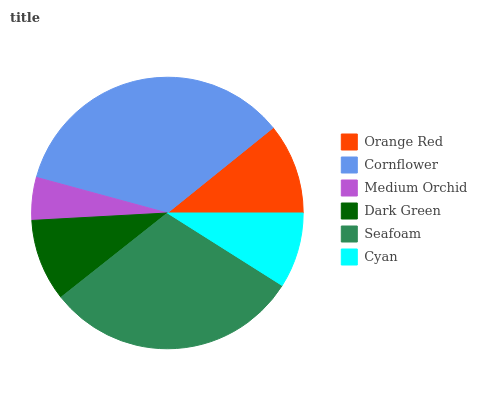Is Medium Orchid the minimum?
Answer yes or no. Yes. Is Cornflower the maximum?
Answer yes or no. Yes. Is Cornflower the minimum?
Answer yes or no. No. Is Medium Orchid the maximum?
Answer yes or no. No. Is Cornflower greater than Medium Orchid?
Answer yes or no. Yes. Is Medium Orchid less than Cornflower?
Answer yes or no. Yes. Is Medium Orchid greater than Cornflower?
Answer yes or no. No. Is Cornflower less than Medium Orchid?
Answer yes or no. No. Is Orange Red the high median?
Answer yes or no. Yes. Is Dark Green the low median?
Answer yes or no. Yes. Is Dark Green the high median?
Answer yes or no. No. Is Medium Orchid the low median?
Answer yes or no. No. 